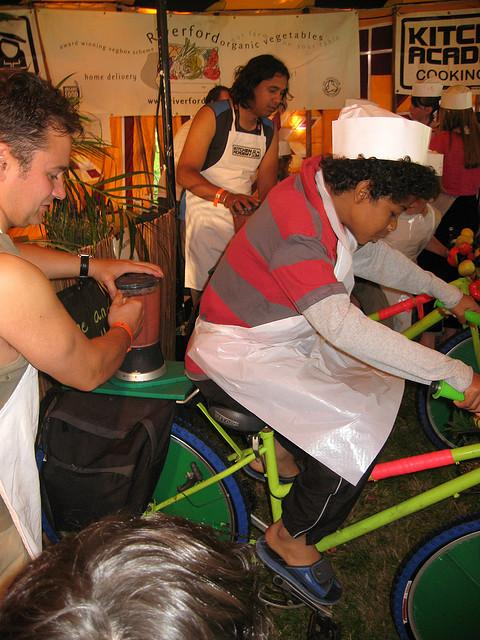What does the person in the white hat power?

Choices:
A) nothing
B) blender
C) forward movement
D) aerobic blender 